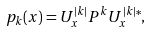<formula> <loc_0><loc_0><loc_500><loc_500>p _ { k } ( x ) = U ^ { | k | } _ { x } P ^ { k } U _ { x } ^ { | k | * } ,</formula> 